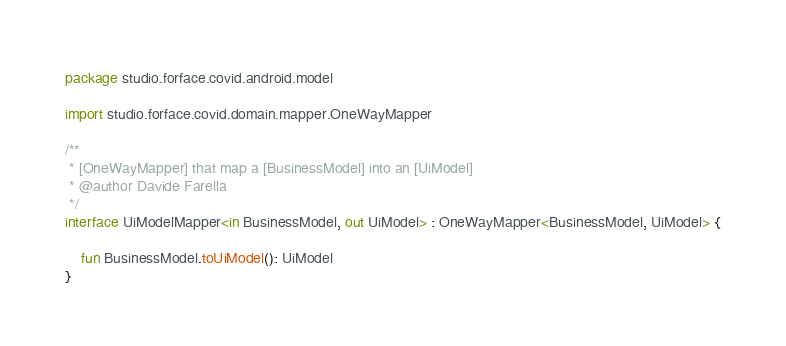<code> <loc_0><loc_0><loc_500><loc_500><_Kotlin_>package studio.forface.covid.android.model

import studio.forface.covid.domain.mapper.OneWayMapper

/**
 * [OneWayMapper] that map a [BusinessModel] into an [UiModel]
 * @author Davide Farella
 */
interface UiModelMapper<in BusinessModel, out UiModel> : OneWayMapper<BusinessModel, UiModel> {

    fun BusinessModel.toUiModel(): UiModel
}
</code> 